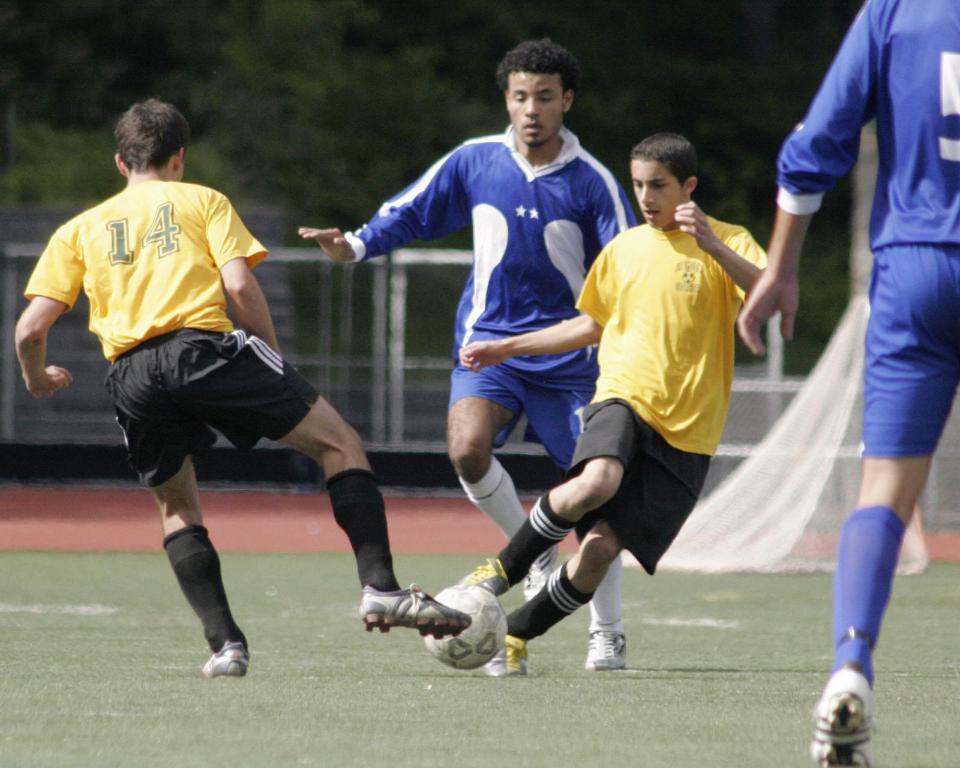Could you give a brief overview of what you see in this image? In the image we can see there are people who are standing and they are playing with a football on the ground. The ground is covered with grass and the people are wearing uniform, at the back there are lot of trees. 